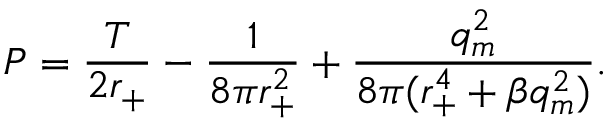<formula> <loc_0><loc_0><loc_500><loc_500>P = \frac { T } { 2 r _ { + } } - \frac { 1 } { 8 \pi r _ { + } ^ { 2 } } + \frac { q _ { m } ^ { 2 } } { 8 \pi ( r _ { + } ^ { 4 } + \beta q _ { m } ^ { 2 } ) } .</formula> 